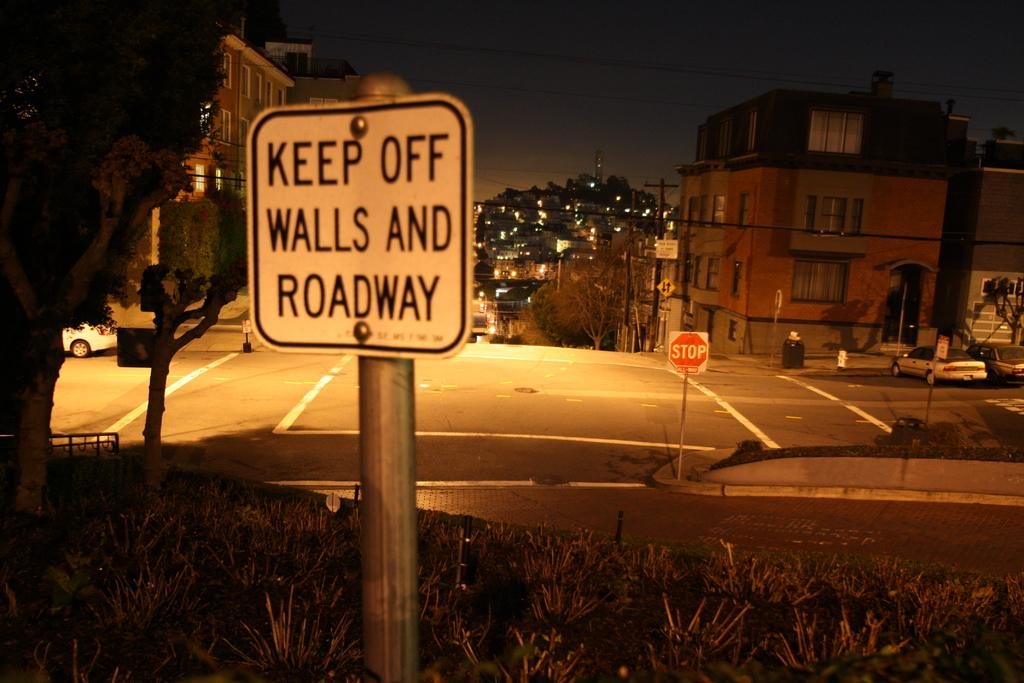<image>
Share a concise interpretation of the image provided. a keep off walls and roadway sign that is on the street 